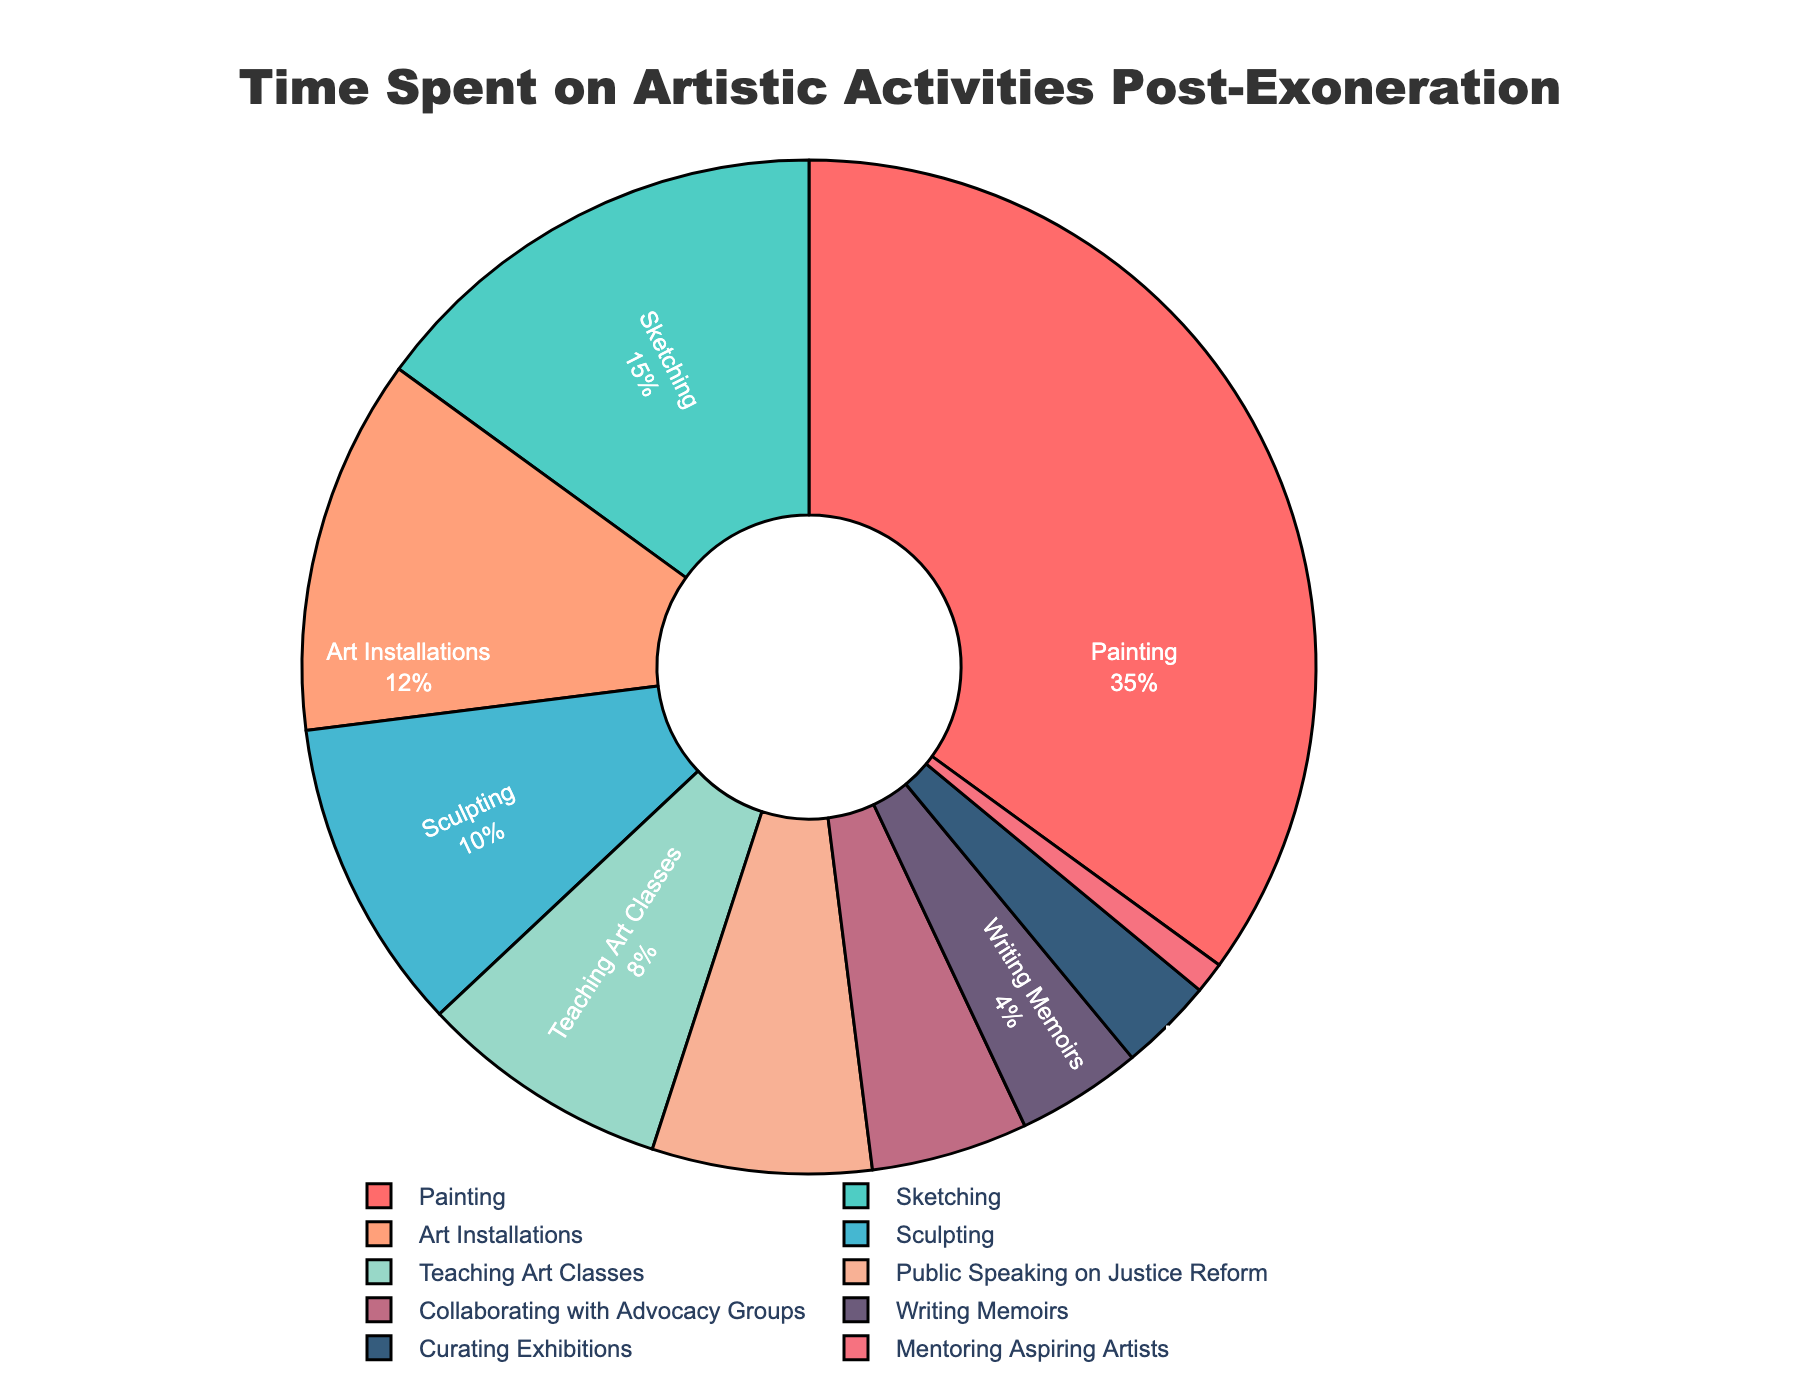How much time is spent on painting compared to mentoring aspiring artists? The percentage of time spent on painting is 35%, while mentoring aspiring artists is 1%. To compare, 35% - 1% = 34% more time is spent on painting.
Answer: 34% Which activity constitutes the smallest percentage of time? According to the pie chart, mentoring aspiring artists has the smallest percentage of time, which is 1%.
Answer: Mentoring Aspiring Artists What are the total percentage of time spent on creating art-related activities (Painting, Sketching, Sculpting, Art Installations)? Adding the percentages of painting, sketching, sculpting, and art installations: 35% + 15% + 10% + 12% = 72%
Answer: 72% Is more time spent on public speaking on justice reform or collaborating with advocacy groups? Public speaking on justice reform takes up 7% of the time, while collaborating with advocacy groups takes up 5%. Since 7% > 5%, more time is spent on public speaking.
Answer: Public Speaking on Justice Reform Which activities cumulatively make up more than 50% of the time spent? Summing up the activities from the largest until the cumulative percentage exceeds 50%: Painting (35%) + Sketching (15%) = 50%. These two activities combined make up 50%, and adding any other activity exceeds 50%.
Answer: Painting, Sketching How much more time is dedicated to teaching art classes than writing memoirs? Teaching art classes account for 8% of the time, while writing memoirs accounts for 4%. The difference is 8% - 4% = 4%.
Answer: 4% What is the combined percentage of time spent on activities related to teaching or mentoring? Adding the percentages of teaching art classes and mentoring aspiring artists: 8% + 1% = 9%
Answer: 9% Which has a larger percentage: curating exhibitions or sculpting? The percentage for curating exhibitions is 3%, and for sculpting it is 10%. Since 10% > 3%, sculpting has a larger percentage.
Answer: Sculpting Is the percentage of time spent on teaching art classes greater than half of the time spent on sketching? Half of the time spent on sketching is 15% / 2 = 7.5%. Teaching art classes is 8%, which is greater than 7.5%.
Answer: Yes What is the difference between the percentage of time spent on the two activities with the highest proportions? The two highest percentages are painting (35%) and sketching (15%). The difference is 35% - 15% = 20%.
Answer: 20% 